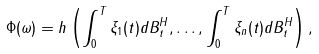Convert formula to latex. <formula><loc_0><loc_0><loc_500><loc_500>\Phi ( \omega ) = h \left ( \int _ { 0 } ^ { T } \xi _ { 1 } ( t ) d B _ { t } ^ { H } , \dots , \int _ { 0 } ^ { T } \xi _ { n } ( t ) d B _ { t } ^ { H } \right ) ,</formula> 